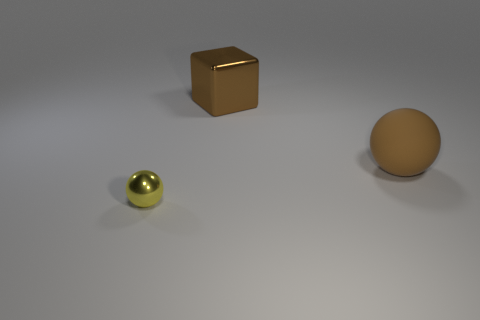Is there anything else that has the same material as the large brown ball?
Offer a terse response. No. There is a metallic cube that is the same color as the big matte sphere; what size is it?
Ensure brevity in your answer.  Large. There is a rubber thing that is the same size as the brown shiny thing; what color is it?
Ensure brevity in your answer.  Brown. What number of other tiny objects are the same shape as the tiny yellow thing?
Ensure brevity in your answer.  0. What number of blocks are either rubber things or large brown objects?
Ensure brevity in your answer.  1. There is a large brown thing behind the big brown ball; is it the same shape as the metal object in front of the large brown ball?
Your answer should be compact. No. What is the material of the big ball?
Give a very brief answer. Rubber. What shape is the big rubber thing that is the same color as the large metallic block?
Your answer should be compact. Sphere. What number of cyan spheres are the same size as the rubber object?
Ensure brevity in your answer.  0. What number of things are objects that are in front of the big matte sphere or brown things that are right of the brown metallic cube?
Offer a terse response. 2. 